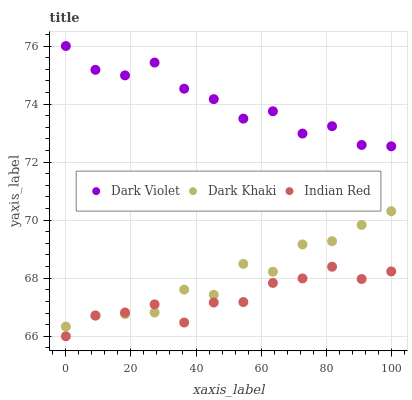Does Indian Red have the minimum area under the curve?
Answer yes or no. Yes. Does Dark Violet have the maximum area under the curve?
Answer yes or no. Yes. Does Dark Violet have the minimum area under the curve?
Answer yes or no. No. Does Indian Red have the maximum area under the curve?
Answer yes or no. No. Is Indian Red the smoothest?
Answer yes or no. Yes. Is Dark Violet the roughest?
Answer yes or no. Yes. Is Dark Violet the smoothest?
Answer yes or no. No. Is Indian Red the roughest?
Answer yes or no. No. Does Indian Red have the lowest value?
Answer yes or no. Yes. Does Dark Violet have the lowest value?
Answer yes or no. No. Does Dark Violet have the highest value?
Answer yes or no. Yes. Does Indian Red have the highest value?
Answer yes or no. No. Is Dark Khaki less than Dark Violet?
Answer yes or no. Yes. Is Dark Violet greater than Dark Khaki?
Answer yes or no. Yes. Does Indian Red intersect Dark Khaki?
Answer yes or no. Yes. Is Indian Red less than Dark Khaki?
Answer yes or no. No. Is Indian Red greater than Dark Khaki?
Answer yes or no. No. Does Dark Khaki intersect Dark Violet?
Answer yes or no. No. 